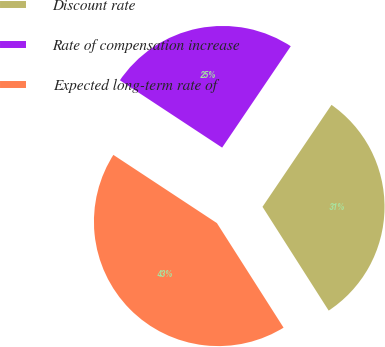Convert chart. <chart><loc_0><loc_0><loc_500><loc_500><pie_chart><fcel>Discount rate<fcel>Rate of compensation increase<fcel>Expected long-term rate of<nl><fcel>31.5%<fcel>25.2%<fcel>43.31%<nl></chart> 